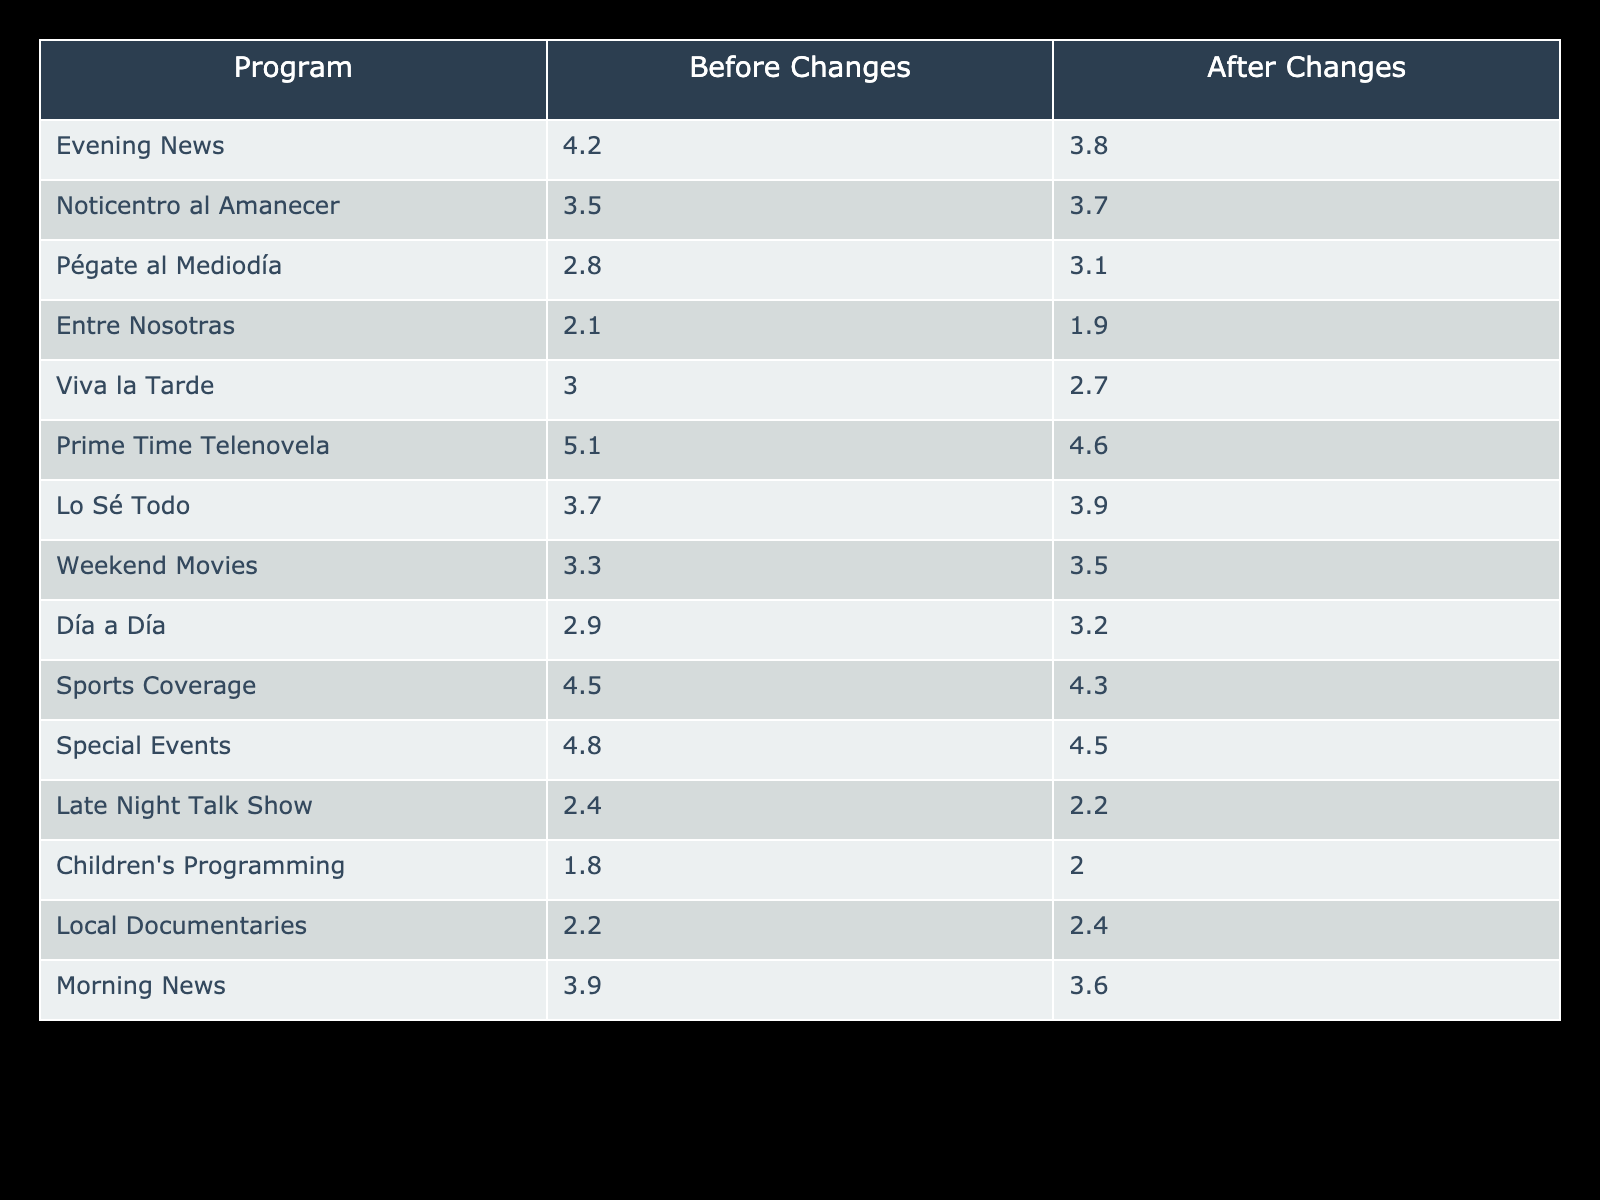What was the rating for "Noticentro al Amanecer" before the changes? The rating for "Noticentro al Amanecer" before the changes is found in the "Before Changes" column next to the program name. The value is 3.5.
Answer: 3.5 Did "Entre Nosotras" experience an increase in ratings after the changes? To determine this, we compare the ratings for "Entre Nosotras" in both columns. The rating before changes was 2.1, and after changes, it was 1.9. Since 1.9 is less than 2.1, it indicates a decrease.
Answer: No What is the difference in ratings for "Prime Time Telenovela" before and after the changes? The difference can be calculated by subtracting the "After Changes" value from the "Before Changes" value. The rating was 5.1 before and 4.6 after, so the difference is 5.1 - 4.6 = 0.5.
Answer: 0.5 Which program had the highest rating after the changes? We look for the program with the maximum value in the "After Changes" column. "Noticentro al Amanecer" has the highest rating of 3.7 after the changes.
Answer: 3.7 What is the average rating before the changes for all programs listed? To calculate the average, we first sum up all the values in the "Before Changes" column: 4.2 + 3.5 + 2.8 + 2.1 + 3.0 + 5.1 + 3.7 + 3.3 + 2.9 + 4.5 + 4.8 + 2.4 + 1.8 + 2.2 + 3.9 =  57.9. There are 15 entries, thus the average rating is 57.9 / 15 = 3.86.
Answer: 3.86 Did the ratings for the "Weekend Movies" program improve after the changes? We compare the ratings for "Weekend Movies" before and after. The rating was 3.3 before and after the changes, it has gone up to 3.5. Since 3.5 is greater than 3.3, this signifies an improvement.
Answer: Yes What is the total rating decrease across all programs after the changes? To find the total decrease, we subtract the sum of ratings after changes from the sum of ratings before changes. Total before: 57.9, Total after: 54.3 (3.8 + 3.7 + 3.1 + 1.9 + 2.7 + 4.6 + 3.9 + 3.5 + 3.2 + 4.3 + 4.5 + 2.2 + 2.0 + 2.4 + 3.6 = 54.3). The total decrease is 57.9 - 54.3 = 3.6.
Answer: 3.6 Which program had the lowest rating after the changes? We look for the program with the lowest value in the "After Changes" column. "Entre Nosotras" has the lowest rating of 1.9 after the changes.
Answer: 1.9 